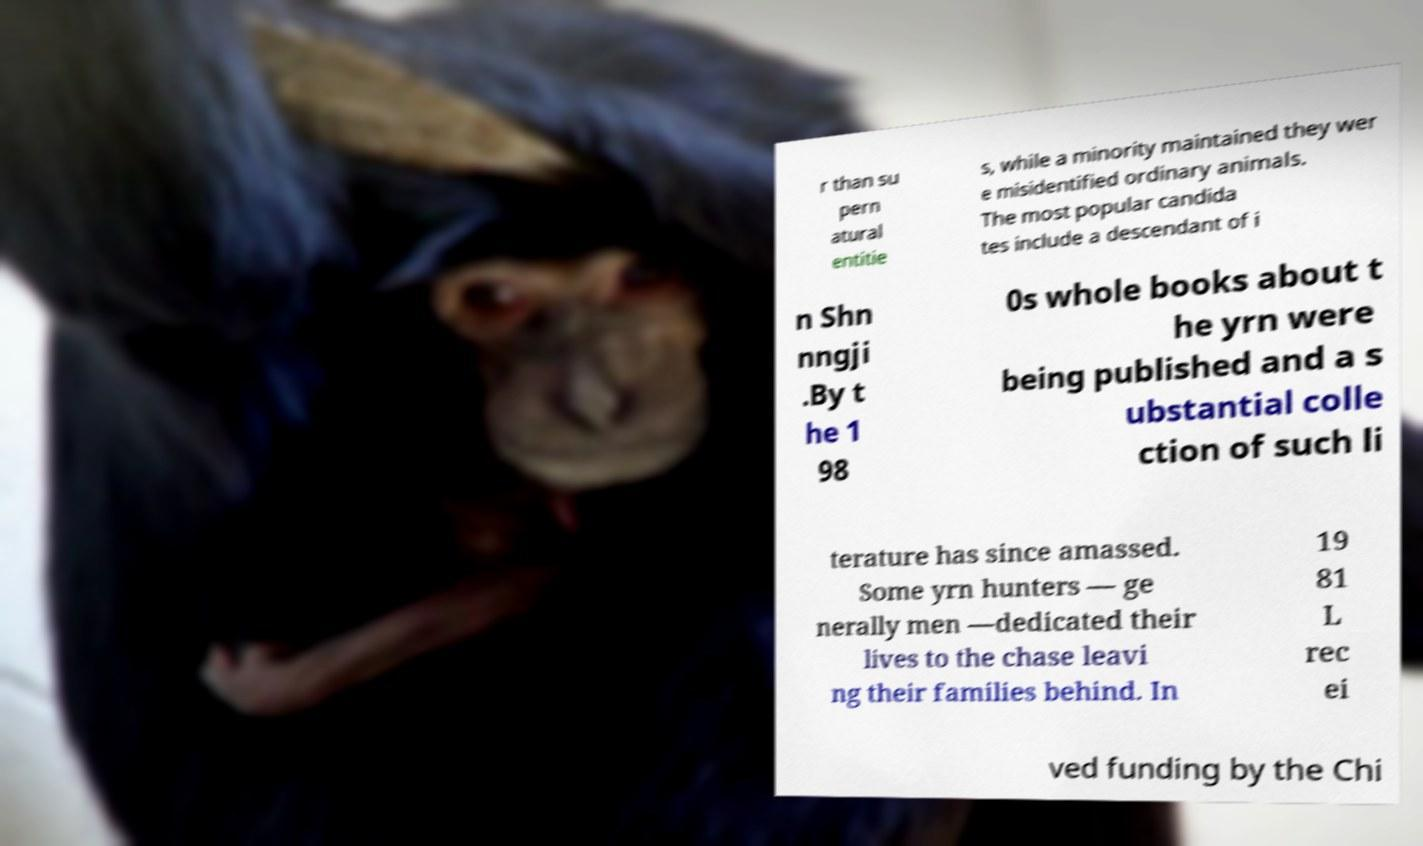There's text embedded in this image that I need extracted. Can you transcribe it verbatim? r than su pern atural entitie s, while a minority maintained they wer e misidentified ordinary animals. The most popular candida tes include a descendant of i n Shn nngji .By t he 1 98 0s whole books about t he yrn were being published and a s ubstantial colle ction of such li terature has since amassed. Some yrn hunters — ge nerally men —dedicated their lives to the chase leavi ng their families behind. In 19 81 L rec ei ved funding by the Chi 